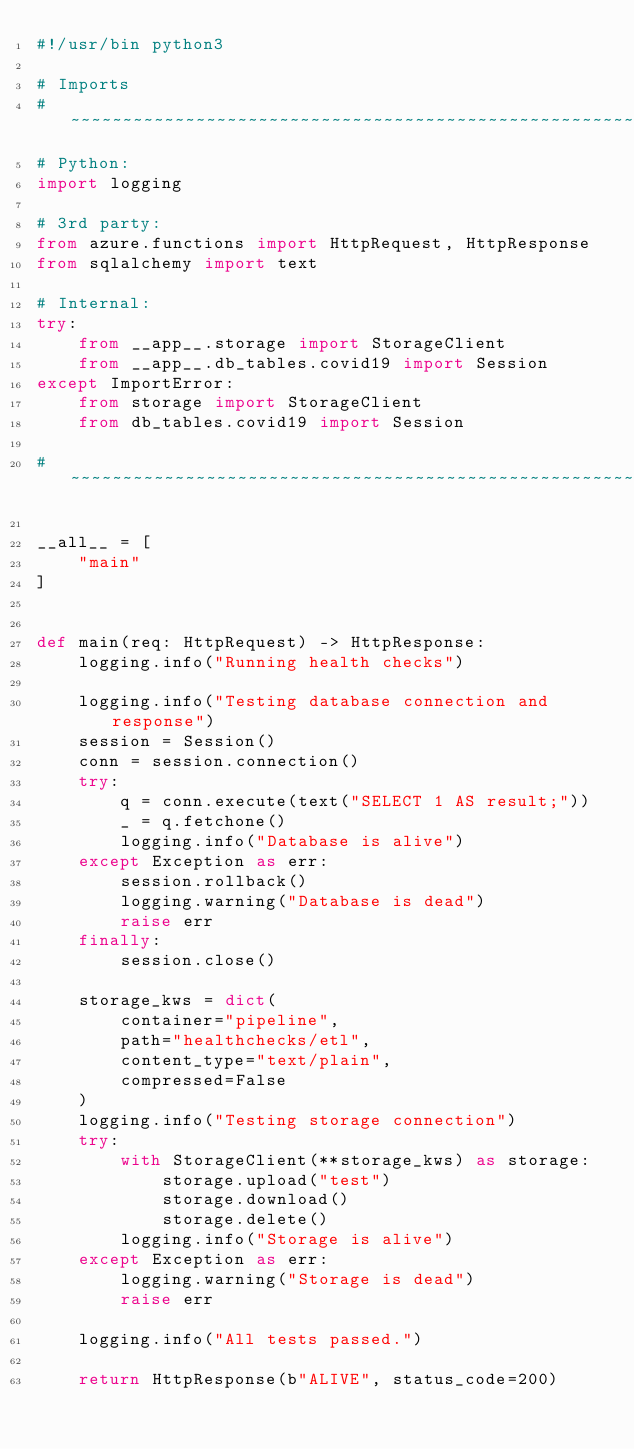<code> <loc_0><loc_0><loc_500><loc_500><_Python_>#!/usr/bin python3

# Imports
# ~~~~~~~~~~~~~~~~~~~~~~~~~~~~~~~~~~~~~~~~~~~~~~~~~~~~~~~~~~~~~~~~~~~~~~~~~~~~~~~~~~~~~~~~
# Python:
import logging

# 3rd party:
from azure.functions import HttpRequest, HttpResponse
from sqlalchemy import text

# Internal: 
try:
    from __app__.storage import StorageClient
    from __app__.db_tables.covid19 import Session
except ImportError:
    from storage import StorageClient
    from db_tables.covid19 import Session

# ~~~~~~~~~~~~~~~~~~~~~~~~~~~~~~~~~~~~~~~~~~~~~~~~~~~~~~~~~~~~~~~~~~~~~~~~~~~~~~~~~~~~~~~~

__all__ = [
    "main"
]


def main(req: HttpRequest) -> HttpResponse:
    logging.info("Running health checks")

    logging.info("Testing database connection and response")
    session = Session()
    conn = session.connection()
    try:
        q = conn.execute(text("SELECT 1 AS result;"))
        _ = q.fetchone()
        logging.info("Database is alive")
    except Exception as err:
        session.rollback()
        logging.warning("Database is dead")
        raise err
    finally:
        session.close()

    storage_kws = dict(
        container="pipeline",
        path="healthchecks/etl",
        content_type="text/plain",
        compressed=False
    )
    logging.info("Testing storage connection")
    try:
        with StorageClient(**storage_kws) as storage:
            storage.upload("test")
            storage.download()
            storage.delete()
        logging.info("Storage is alive")
    except Exception as err:
        logging.warning("Storage is dead")
        raise err

    logging.info("All tests passed.")

    return HttpResponse(b"ALIVE", status_code=200)
</code> 